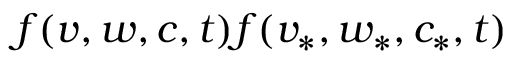<formula> <loc_0><loc_0><loc_500><loc_500>f ( v , w , c , t ) f ( v _ { * } , w _ { * } , c _ { * } , t )</formula> 